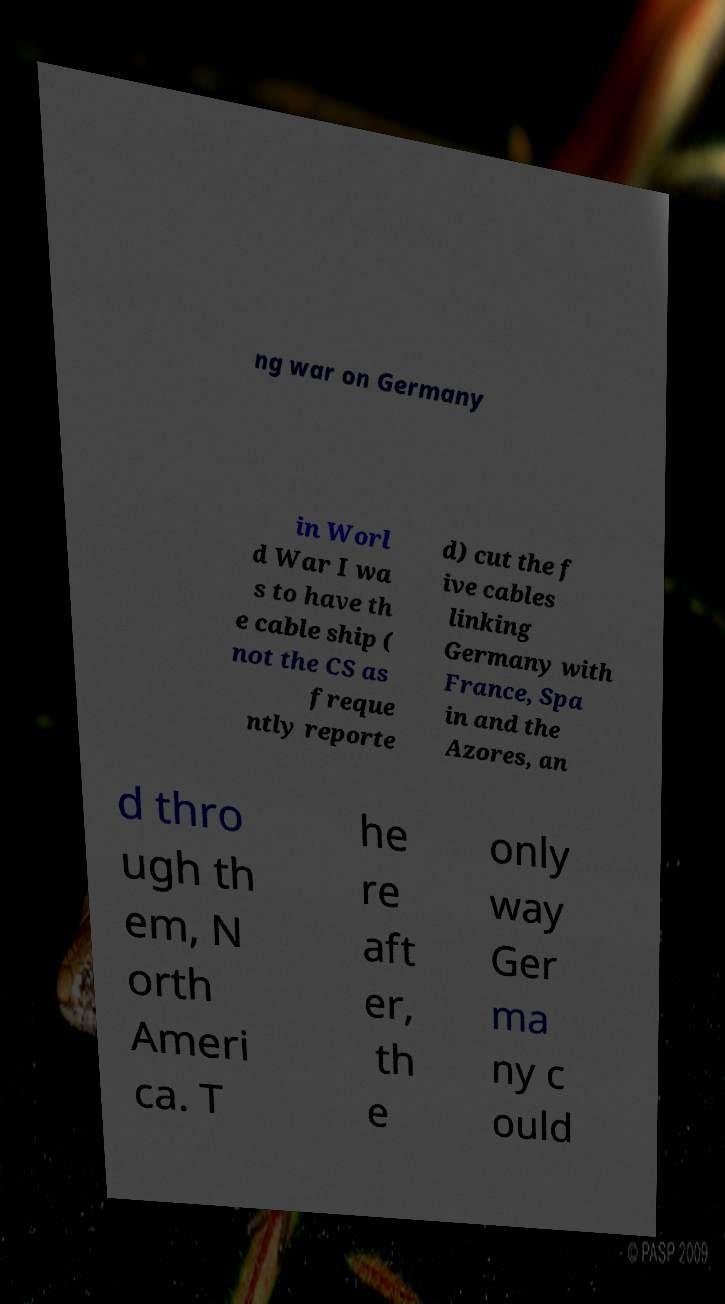For documentation purposes, I need the text within this image transcribed. Could you provide that? ng war on Germany in Worl d War I wa s to have th e cable ship ( not the CS as freque ntly reporte d) cut the f ive cables linking Germany with France, Spa in and the Azores, an d thro ugh th em, N orth Ameri ca. T he re aft er, th e only way Ger ma ny c ould 